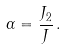Convert formula to latex. <formula><loc_0><loc_0><loc_500><loc_500>\alpha = \frac { J _ { 2 } } { J } \, .</formula> 